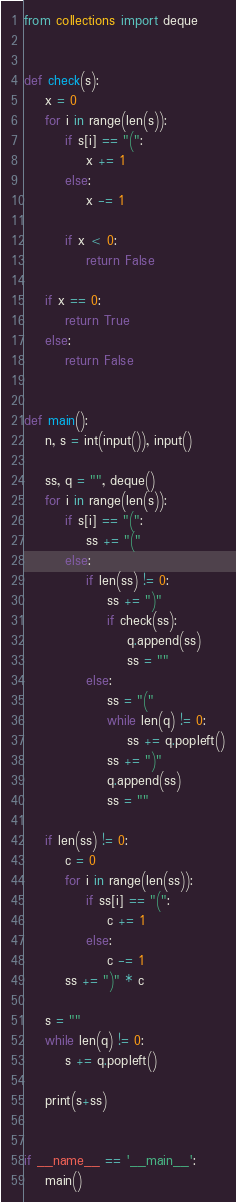Convert code to text. <code><loc_0><loc_0><loc_500><loc_500><_Python_>from collections import deque


def check(s):
    x = 0
    for i in range(len(s)):
        if s[i] == "(":
            x += 1
        else:
            x -= 1

        if x < 0:
            return False

    if x == 0:
        return True
    else:
        return False


def main():
    n, s = int(input()), input()

    ss, q = "", deque()
    for i in range(len(s)):
        if s[i] == "(":
            ss += "("
        else:
            if len(ss) != 0:
                ss += ")"
                if check(ss):
                    q.append(ss)
                    ss = ""
            else:
                ss = "("
                while len(q) != 0:
                    ss += q.popleft()
                ss += ")"
                q.append(ss)
                ss = ""

    if len(ss) != 0:
        c = 0
        for i in range(len(ss)):
            if ss[i] == "(":
                c += 1
            else:
                c -= 1
        ss += ")" * c

    s = ""
    while len(q) != 0:
        s += q.popleft()

    print(s+ss)


if __name__ == '__main__':
    main()
</code> 